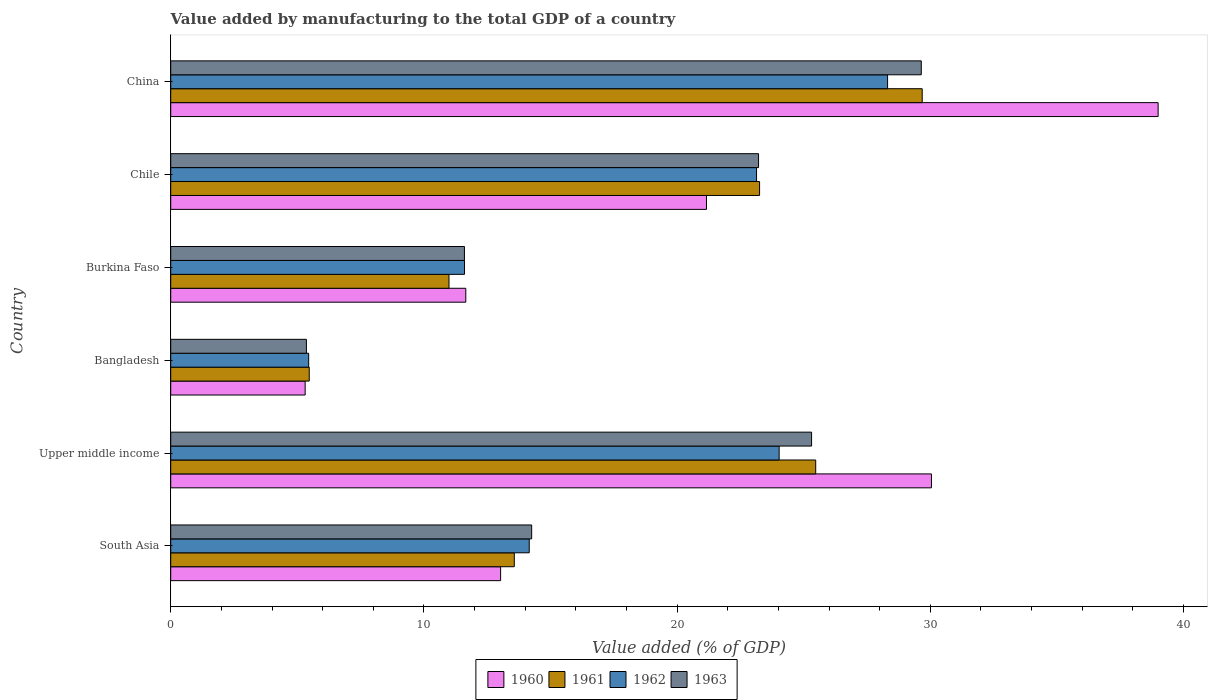How many groups of bars are there?
Ensure brevity in your answer.  6. Are the number of bars per tick equal to the number of legend labels?
Offer a terse response. Yes. How many bars are there on the 1st tick from the top?
Offer a very short reply. 4. How many bars are there on the 4th tick from the bottom?
Provide a succinct answer. 4. What is the label of the 2nd group of bars from the top?
Keep it short and to the point. Chile. What is the value added by manufacturing to the total GDP in 1963 in Bangladesh?
Offer a terse response. 5.36. Across all countries, what is the maximum value added by manufacturing to the total GDP in 1960?
Your answer should be compact. 39. Across all countries, what is the minimum value added by manufacturing to the total GDP in 1960?
Make the answer very short. 5.31. In which country was the value added by manufacturing to the total GDP in 1961 minimum?
Ensure brevity in your answer.  Bangladesh. What is the total value added by manufacturing to the total GDP in 1961 in the graph?
Offer a terse response. 108.44. What is the difference between the value added by manufacturing to the total GDP in 1961 in Bangladesh and that in Upper middle income?
Offer a terse response. -20. What is the difference between the value added by manufacturing to the total GDP in 1961 in South Asia and the value added by manufacturing to the total GDP in 1962 in China?
Make the answer very short. -14.74. What is the average value added by manufacturing to the total GDP in 1962 per country?
Give a very brief answer. 17.78. What is the difference between the value added by manufacturing to the total GDP in 1963 and value added by manufacturing to the total GDP in 1960 in Burkina Faso?
Your response must be concise. -0.05. What is the ratio of the value added by manufacturing to the total GDP in 1962 in Bangladesh to that in Chile?
Offer a terse response. 0.24. Is the difference between the value added by manufacturing to the total GDP in 1963 in Bangladesh and South Asia greater than the difference between the value added by manufacturing to the total GDP in 1960 in Bangladesh and South Asia?
Ensure brevity in your answer.  No. What is the difference between the highest and the second highest value added by manufacturing to the total GDP in 1963?
Offer a very short reply. 4.33. What is the difference between the highest and the lowest value added by manufacturing to the total GDP in 1961?
Ensure brevity in your answer.  24.21. Is the sum of the value added by manufacturing to the total GDP in 1962 in Burkina Faso and Chile greater than the maximum value added by manufacturing to the total GDP in 1961 across all countries?
Your answer should be compact. Yes. Is it the case that in every country, the sum of the value added by manufacturing to the total GDP in 1962 and value added by manufacturing to the total GDP in 1963 is greater than the sum of value added by manufacturing to the total GDP in 1960 and value added by manufacturing to the total GDP in 1961?
Ensure brevity in your answer.  No. What does the 3rd bar from the top in Upper middle income represents?
Provide a succinct answer. 1961. Is it the case that in every country, the sum of the value added by manufacturing to the total GDP in 1960 and value added by manufacturing to the total GDP in 1962 is greater than the value added by manufacturing to the total GDP in 1963?
Provide a short and direct response. Yes. How many bars are there?
Ensure brevity in your answer.  24. Are all the bars in the graph horizontal?
Your answer should be very brief. Yes. Are the values on the major ticks of X-axis written in scientific E-notation?
Provide a succinct answer. No. Does the graph contain any zero values?
Your answer should be very brief. No. Does the graph contain grids?
Ensure brevity in your answer.  No. How are the legend labels stacked?
Offer a terse response. Horizontal. What is the title of the graph?
Offer a very short reply. Value added by manufacturing to the total GDP of a country. Does "2006" appear as one of the legend labels in the graph?
Keep it short and to the point. No. What is the label or title of the X-axis?
Keep it short and to the point. Value added (% of GDP). What is the label or title of the Y-axis?
Your answer should be compact. Country. What is the Value added (% of GDP) of 1960 in South Asia?
Your answer should be very brief. 13.03. What is the Value added (% of GDP) in 1961 in South Asia?
Make the answer very short. 13.57. What is the Value added (% of GDP) in 1962 in South Asia?
Offer a terse response. 14.16. What is the Value added (% of GDP) of 1963 in South Asia?
Offer a terse response. 14.26. What is the Value added (% of GDP) of 1960 in Upper middle income?
Provide a succinct answer. 30.05. What is the Value added (% of GDP) in 1961 in Upper middle income?
Ensure brevity in your answer.  25.47. What is the Value added (% of GDP) of 1962 in Upper middle income?
Your answer should be very brief. 24.03. What is the Value added (% of GDP) in 1963 in Upper middle income?
Your answer should be compact. 25.31. What is the Value added (% of GDP) in 1960 in Bangladesh?
Make the answer very short. 5.31. What is the Value added (% of GDP) of 1961 in Bangladesh?
Provide a succinct answer. 5.47. What is the Value added (% of GDP) of 1962 in Bangladesh?
Provide a succinct answer. 5.45. What is the Value added (% of GDP) in 1963 in Bangladesh?
Give a very brief answer. 5.36. What is the Value added (% of GDP) in 1960 in Burkina Faso?
Offer a very short reply. 11.65. What is the Value added (% of GDP) of 1961 in Burkina Faso?
Offer a terse response. 10.99. What is the Value added (% of GDP) of 1962 in Burkina Faso?
Give a very brief answer. 11.6. What is the Value added (% of GDP) in 1963 in Burkina Faso?
Ensure brevity in your answer.  11.6. What is the Value added (% of GDP) in 1960 in Chile?
Your answer should be compact. 21.16. What is the Value added (% of GDP) of 1961 in Chile?
Ensure brevity in your answer.  23.26. What is the Value added (% of GDP) in 1962 in Chile?
Offer a terse response. 23.14. What is the Value added (% of GDP) in 1963 in Chile?
Make the answer very short. 23.22. What is the Value added (% of GDP) of 1960 in China?
Your answer should be compact. 39. What is the Value added (% of GDP) in 1961 in China?
Keep it short and to the point. 29.68. What is the Value added (% of GDP) of 1962 in China?
Your answer should be very brief. 28.31. What is the Value added (% of GDP) of 1963 in China?
Offer a very short reply. 29.64. Across all countries, what is the maximum Value added (% of GDP) in 1960?
Your response must be concise. 39. Across all countries, what is the maximum Value added (% of GDP) in 1961?
Ensure brevity in your answer.  29.68. Across all countries, what is the maximum Value added (% of GDP) of 1962?
Your answer should be compact. 28.31. Across all countries, what is the maximum Value added (% of GDP) in 1963?
Your answer should be compact. 29.64. Across all countries, what is the minimum Value added (% of GDP) in 1960?
Your response must be concise. 5.31. Across all countries, what is the minimum Value added (% of GDP) of 1961?
Make the answer very short. 5.47. Across all countries, what is the minimum Value added (% of GDP) of 1962?
Provide a succinct answer. 5.45. Across all countries, what is the minimum Value added (% of GDP) of 1963?
Give a very brief answer. 5.36. What is the total Value added (% of GDP) of 1960 in the graph?
Your answer should be very brief. 120.2. What is the total Value added (% of GDP) in 1961 in the graph?
Your response must be concise. 108.44. What is the total Value added (% of GDP) of 1962 in the graph?
Your answer should be very brief. 106.69. What is the total Value added (% of GDP) in 1963 in the graph?
Your answer should be compact. 109.39. What is the difference between the Value added (% of GDP) of 1960 in South Asia and that in Upper middle income?
Your answer should be very brief. -17.02. What is the difference between the Value added (% of GDP) in 1961 in South Asia and that in Upper middle income?
Your answer should be compact. -11.9. What is the difference between the Value added (% of GDP) of 1962 in South Asia and that in Upper middle income?
Your answer should be compact. -9.87. What is the difference between the Value added (% of GDP) of 1963 in South Asia and that in Upper middle income?
Your response must be concise. -11.05. What is the difference between the Value added (% of GDP) of 1960 in South Asia and that in Bangladesh?
Provide a succinct answer. 7.72. What is the difference between the Value added (% of GDP) of 1961 in South Asia and that in Bangladesh?
Provide a succinct answer. 8.1. What is the difference between the Value added (% of GDP) of 1962 in South Asia and that in Bangladesh?
Offer a terse response. 8.71. What is the difference between the Value added (% of GDP) of 1963 in South Asia and that in Bangladesh?
Keep it short and to the point. 8.9. What is the difference between the Value added (% of GDP) in 1960 in South Asia and that in Burkina Faso?
Offer a very short reply. 1.37. What is the difference between the Value added (% of GDP) of 1961 in South Asia and that in Burkina Faso?
Your answer should be very brief. 2.58. What is the difference between the Value added (% of GDP) in 1962 in South Asia and that in Burkina Faso?
Provide a short and direct response. 2.56. What is the difference between the Value added (% of GDP) of 1963 in South Asia and that in Burkina Faso?
Give a very brief answer. 2.66. What is the difference between the Value added (% of GDP) in 1960 in South Asia and that in Chile?
Your answer should be very brief. -8.13. What is the difference between the Value added (% of GDP) of 1961 in South Asia and that in Chile?
Your answer should be compact. -9.69. What is the difference between the Value added (% of GDP) in 1962 in South Asia and that in Chile?
Make the answer very short. -8.98. What is the difference between the Value added (% of GDP) in 1963 in South Asia and that in Chile?
Your answer should be compact. -8.96. What is the difference between the Value added (% of GDP) of 1960 in South Asia and that in China?
Provide a succinct answer. -25.97. What is the difference between the Value added (% of GDP) in 1961 in South Asia and that in China?
Ensure brevity in your answer.  -16.11. What is the difference between the Value added (% of GDP) in 1962 in South Asia and that in China?
Your answer should be compact. -14.15. What is the difference between the Value added (% of GDP) in 1963 in South Asia and that in China?
Give a very brief answer. -15.39. What is the difference between the Value added (% of GDP) in 1960 in Upper middle income and that in Bangladesh?
Give a very brief answer. 24.74. What is the difference between the Value added (% of GDP) in 1961 in Upper middle income and that in Bangladesh?
Keep it short and to the point. 20. What is the difference between the Value added (% of GDP) of 1962 in Upper middle income and that in Bangladesh?
Offer a terse response. 18.58. What is the difference between the Value added (% of GDP) in 1963 in Upper middle income and that in Bangladesh?
Provide a short and direct response. 19.95. What is the difference between the Value added (% of GDP) of 1960 in Upper middle income and that in Burkina Faso?
Make the answer very short. 18.39. What is the difference between the Value added (% of GDP) in 1961 in Upper middle income and that in Burkina Faso?
Give a very brief answer. 14.48. What is the difference between the Value added (% of GDP) in 1962 in Upper middle income and that in Burkina Faso?
Your response must be concise. 12.43. What is the difference between the Value added (% of GDP) in 1963 in Upper middle income and that in Burkina Faso?
Your answer should be very brief. 13.71. What is the difference between the Value added (% of GDP) of 1960 in Upper middle income and that in Chile?
Your response must be concise. 8.89. What is the difference between the Value added (% of GDP) in 1961 in Upper middle income and that in Chile?
Ensure brevity in your answer.  2.22. What is the difference between the Value added (% of GDP) in 1962 in Upper middle income and that in Chile?
Keep it short and to the point. 0.89. What is the difference between the Value added (% of GDP) of 1963 in Upper middle income and that in Chile?
Ensure brevity in your answer.  2.09. What is the difference between the Value added (% of GDP) in 1960 in Upper middle income and that in China?
Make the answer very short. -8.95. What is the difference between the Value added (% of GDP) in 1961 in Upper middle income and that in China?
Provide a short and direct response. -4.21. What is the difference between the Value added (% of GDP) in 1962 in Upper middle income and that in China?
Your answer should be compact. -4.28. What is the difference between the Value added (% of GDP) in 1963 in Upper middle income and that in China?
Offer a terse response. -4.33. What is the difference between the Value added (% of GDP) of 1960 in Bangladesh and that in Burkina Faso?
Provide a succinct answer. -6.34. What is the difference between the Value added (% of GDP) in 1961 in Bangladesh and that in Burkina Faso?
Offer a very short reply. -5.52. What is the difference between the Value added (% of GDP) in 1962 in Bangladesh and that in Burkina Faso?
Keep it short and to the point. -6.16. What is the difference between the Value added (% of GDP) in 1963 in Bangladesh and that in Burkina Faso?
Keep it short and to the point. -6.24. What is the difference between the Value added (% of GDP) in 1960 in Bangladesh and that in Chile?
Make the answer very short. -15.85. What is the difference between the Value added (% of GDP) of 1961 in Bangladesh and that in Chile?
Your answer should be compact. -17.79. What is the difference between the Value added (% of GDP) in 1962 in Bangladesh and that in Chile?
Provide a succinct answer. -17.69. What is the difference between the Value added (% of GDP) of 1963 in Bangladesh and that in Chile?
Make the answer very short. -17.86. What is the difference between the Value added (% of GDP) of 1960 in Bangladesh and that in China?
Provide a short and direct response. -33.69. What is the difference between the Value added (% of GDP) in 1961 in Bangladesh and that in China?
Your response must be concise. -24.21. What is the difference between the Value added (% of GDP) in 1962 in Bangladesh and that in China?
Ensure brevity in your answer.  -22.86. What is the difference between the Value added (% of GDP) of 1963 in Bangladesh and that in China?
Your response must be concise. -24.28. What is the difference between the Value added (% of GDP) of 1960 in Burkina Faso and that in Chile?
Provide a succinct answer. -9.51. What is the difference between the Value added (% of GDP) of 1961 in Burkina Faso and that in Chile?
Provide a succinct answer. -12.27. What is the difference between the Value added (% of GDP) of 1962 in Burkina Faso and that in Chile?
Ensure brevity in your answer.  -11.53. What is the difference between the Value added (% of GDP) in 1963 in Burkina Faso and that in Chile?
Your answer should be compact. -11.62. What is the difference between the Value added (% of GDP) of 1960 in Burkina Faso and that in China?
Your response must be concise. -27.34. What is the difference between the Value added (% of GDP) in 1961 in Burkina Faso and that in China?
Provide a short and direct response. -18.69. What is the difference between the Value added (% of GDP) in 1962 in Burkina Faso and that in China?
Provide a succinct answer. -16.71. What is the difference between the Value added (% of GDP) of 1963 in Burkina Faso and that in China?
Make the answer very short. -18.04. What is the difference between the Value added (% of GDP) of 1960 in Chile and that in China?
Give a very brief answer. -17.84. What is the difference between the Value added (% of GDP) of 1961 in Chile and that in China?
Your answer should be very brief. -6.42. What is the difference between the Value added (% of GDP) in 1962 in Chile and that in China?
Your answer should be very brief. -5.17. What is the difference between the Value added (% of GDP) in 1963 in Chile and that in China?
Offer a very short reply. -6.43. What is the difference between the Value added (% of GDP) of 1960 in South Asia and the Value added (% of GDP) of 1961 in Upper middle income?
Provide a succinct answer. -12.44. What is the difference between the Value added (% of GDP) in 1960 in South Asia and the Value added (% of GDP) in 1962 in Upper middle income?
Provide a short and direct response. -11. What is the difference between the Value added (% of GDP) in 1960 in South Asia and the Value added (% of GDP) in 1963 in Upper middle income?
Provide a short and direct response. -12.28. What is the difference between the Value added (% of GDP) in 1961 in South Asia and the Value added (% of GDP) in 1962 in Upper middle income?
Your answer should be compact. -10.46. What is the difference between the Value added (% of GDP) of 1961 in South Asia and the Value added (% of GDP) of 1963 in Upper middle income?
Offer a terse response. -11.74. What is the difference between the Value added (% of GDP) in 1962 in South Asia and the Value added (% of GDP) in 1963 in Upper middle income?
Your response must be concise. -11.15. What is the difference between the Value added (% of GDP) in 1960 in South Asia and the Value added (% of GDP) in 1961 in Bangladesh?
Ensure brevity in your answer.  7.56. What is the difference between the Value added (% of GDP) in 1960 in South Asia and the Value added (% of GDP) in 1962 in Bangladesh?
Provide a short and direct response. 7.58. What is the difference between the Value added (% of GDP) of 1960 in South Asia and the Value added (% of GDP) of 1963 in Bangladesh?
Your answer should be compact. 7.67. What is the difference between the Value added (% of GDP) in 1961 in South Asia and the Value added (% of GDP) in 1962 in Bangladesh?
Offer a terse response. 8.12. What is the difference between the Value added (% of GDP) of 1961 in South Asia and the Value added (% of GDP) of 1963 in Bangladesh?
Offer a terse response. 8.21. What is the difference between the Value added (% of GDP) in 1962 in South Asia and the Value added (% of GDP) in 1963 in Bangladesh?
Offer a terse response. 8.8. What is the difference between the Value added (% of GDP) in 1960 in South Asia and the Value added (% of GDP) in 1961 in Burkina Faso?
Your response must be concise. 2.04. What is the difference between the Value added (% of GDP) of 1960 in South Asia and the Value added (% of GDP) of 1962 in Burkina Faso?
Your answer should be compact. 1.43. What is the difference between the Value added (% of GDP) of 1960 in South Asia and the Value added (% of GDP) of 1963 in Burkina Faso?
Keep it short and to the point. 1.43. What is the difference between the Value added (% of GDP) in 1961 in South Asia and the Value added (% of GDP) in 1962 in Burkina Faso?
Your answer should be compact. 1.97. What is the difference between the Value added (% of GDP) in 1961 in South Asia and the Value added (% of GDP) in 1963 in Burkina Faso?
Your response must be concise. 1.97. What is the difference between the Value added (% of GDP) in 1962 in South Asia and the Value added (% of GDP) in 1963 in Burkina Faso?
Your answer should be very brief. 2.56. What is the difference between the Value added (% of GDP) in 1960 in South Asia and the Value added (% of GDP) in 1961 in Chile?
Offer a very short reply. -10.23. What is the difference between the Value added (% of GDP) of 1960 in South Asia and the Value added (% of GDP) of 1962 in Chile?
Your answer should be compact. -10.11. What is the difference between the Value added (% of GDP) in 1960 in South Asia and the Value added (% of GDP) in 1963 in Chile?
Offer a terse response. -10.19. What is the difference between the Value added (% of GDP) of 1961 in South Asia and the Value added (% of GDP) of 1962 in Chile?
Ensure brevity in your answer.  -9.57. What is the difference between the Value added (% of GDP) of 1961 in South Asia and the Value added (% of GDP) of 1963 in Chile?
Provide a succinct answer. -9.65. What is the difference between the Value added (% of GDP) of 1962 in South Asia and the Value added (% of GDP) of 1963 in Chile?
Keep it short and to the point. -9.06. What is the difference between the Value added (% of GDP) of 1960 in South Asia and the Value added (% of GDP) of 1961 in China?
Offer a very short reply. -16.65. What is the difference between the Value added (% of GDP) of 1960 in South Asia and the Value added (% of GDP) of 1962 in China?
Provide a short and direct response. -15.28. What is the difference between the Value added (% of GDP) of 1960 in South Asia and the Value added (% of GDP) of 1963 in China?
Provide a succinct answer. -16.62. What is the difference between the Value added (% of GDP) of 1961 in South Asia and the Value added (% of GDP) of 1962 in China?
Your answer should be compact. -14.74. What is the difference between the Value added (% of GDP) of 1961 in South Asia and the Value added (% of GDP) of 1963 in China?
Make the answer very short. -16.07. What is the difference between the Value added (% of GDP) in 1962 in South Asia and the Value added (% of GDP) in 1963 in China?
Give a very brief answer. -15.48. What is the difference between the Value added (% of GDP) of 1960 in Upper middle income and the Value added (% of GDP) of 1961 in Bangladesh?
Provide a short and direct response. 24.57. What is the difference between the Value added (% of GDP) in 1960 in Upper middle income and the Value added (% of GDP) in 1962 in Bangladesh?
Offer a terse response. 24.6. What is the difference between the Value added (% of GDP) of 1960 in Upper middle income and the Value added (% of GDP) of 1963 in Bangladesh?
Your response must be concise. 24.69. What is the difference between the Value added (% of GDP) in 1961 in Upper middle income and the Value added (% of GDP) in 1962 in Bangladesh?
Provide a succinct answer. 20.03. What is the difference between the Value added (% of GDP) in 1961 in Upper middle income and the Value added (% of GDP) in 1963 in Bangladesh?
Your answer should be very brief. 20.11. What is the difference between the Value added (% of GDP) of 1962 in Upper middle income and the Value added (% of GDP) of 1963 in Bangladesh?
Your response must be concise. 18.67. What is the difference between the Value added (% of GDP) in 1960 in Upper middle income and the Value added (% of GDP) in 1961 in Burkina Faso?
Provide a succinct answer. 19.05. What is the difference between the Value added (% of GDP) in 1960 in Upper middle income and the Value added (% of GDP) in 1962 in Burkina Faso?
Make the answer very short. 18.44. What is the difference between the Value added (% of GDP) in 1960 in Upper middle income and the Value added (% of GDP) in 1963 in Burkina Faso?
Your answer should be compact. 18.44. What is the difference between the Value added (% of GDP) in 1961 in Upper middle income and the Value added (% of GDP) in 1962 in Burkina Faso?
Offer a terse response. 13.87. What is the difference between the Value added (% of GDP) in 1961 in Upper middle income and the Value added (% of GDP) in 1963 in Burkina Faso?
Provide a succinct answer. 13.87. What is the difference between the Value added (% of GDP) of 1962 in Upper middle income and the Value added (% of GDP) of 1963 in Burkina Faso?
Give a very brief answer. 12.43. What is the difference between the Value added (% of GDP) of 1960 in Upper middle income and the Value added (% of GDP) of 1961 in Chile?
Your response must be concise. 6.79. What is the difference between the Value added (% of GDP) of 1960 in Upper middle income and the Value added (% of GDP) of 1962 in Chile?
Offer a very short reply. 6.91. What is the difference between the Value added (% of GDP) of 1960 in Upper middle income and the Value added (% of GDP) of 1963 in Chile?
Keep it short and to the point. 6.83. What is the difference between the Value added (% of GDP) of 1961 in Upper middle income and the Value added (% of GDP) of 1962 in Chile?
Your answer should be very brief. 2.34. What is the difference between the Value added (% of GDP) in 1961 in Upper middle income and the Value added (% of GDP) in 1963 in Chile?
Your answer should be very brief. 2.26. What is the difference between the Value added (% of GDP) in 1962 in Upper middle income and the Value added (% of GDP) in 1963 in Chile?
Keep it short and to the point. 0.81. What is the difference between the Value added (% of GDP) of 1960 in Upper middle income and the Value added (% of GDP) of 1961 in China?
Give a very brief answer. 0.37. What is the difference between the Value added (% of GDP) in 1960 in Upper middle income and the Value added (% of GDP) in 1962 in China?
Provide a short and direct response. 1.73. What is the difference between the Value added (% of GDP) in 1960 in Upper middle income and the Value added (% of GDP) in 1963 in China?
Provide a succinct answer. 0.4. What is the difference between the Value added (% of GDP) of 1961 in Upper middle income and the Value added (% of GDP) of 1962 in China?
Offer a very short reply. -2.84. What is the difference between the Value added (% of GDP) in 1961 in Upper middle income and the Value added (% of GDP) in 1963 in China?
Ensure brevity in your answer.  -4.17. What is the difference between the Value added (% of GDP) in 1962 in Upper middle income and the Value added (% of GDP) in 1963 in China?
Make the answer very short. -5.61. What is the difference between the Value added (% of GDP) of 1960 in Bangladesh and the Value added (% of GDP) of 1961 in Burkina Faso?
Provide a succinct answer. -5.68. What is the difference between the Value added (% of GDP) of 1960 in Bangladesh and the Value added (% of GDP) of 1962 in Burkina Faso?
Provide a short and direct response. -6.29. What is the difference between the Value added (% of GDP) of 1960 in Bangladesh and the Value added (% of GDP) of 1963 in Burkina Faso?
Provide a succinct answer. -6.29. What is the difference between the Value added (% of GDP) of 1961 in Bangladesh and the Value added (% of GDP) of 1962 in Burkina Faso?
Offer a terse response. -6.13. What is the difference between the Value added (% of GDP) in 1961 in Bangladesh and the Value added (% of GDP) in 1963 in Burkina Faso?
Provide a short and direct response. -6.13. What is the difference between the Value added (% of GDP) of 1962 in Bangladesh and the Value added (% of GDP) of 1963 in Burkina Faso?
Your answer should be compact. -6.15. What is the difference between the Value added (% of GDP) in 1960 in Bangladesh and the Value added (% of GDP) in 1961 in Chile?
Your response must be concise. -17.95. What is the difference between the Value added (% of GDP) in 1960 in Bangladesh and the Value added (% of GDP) in 1962 in Chile?
Keep it short and to the point. -17.83. What is the difference between the Value added (% of GDP) in 1960 in Bangladesh and the Value added (% of GDP) in 1963 in Chile?
Provide a short and direct response. -17.91. What is the difference between the Value added (% of GDP) of 1961 in Bangladesh and the Value added (% of GDP) of 1962 in Chile?
Provide a short and direct response. -17.67. What is the difference between the Value added (% of GDP) in 1961 in Bangladesh and the Value added (% of GDP) in 1963 in Chile?
Your response must be concise. -17.75. What is the difference between the Value added (% of GDP) in 1962 in Bangladesh and the Value added (% of GDP) in 1963 in Chile?
Your answer should be very brief. -17.77. What is the difference between the Value added (% of GDP) in 1960 in Bangladesh and the Value added (% of GDP) in 1961 in China?
Offer a terse response. -24.37. What is the difference between the Value added (% of GDP) in 1960 in Bangladesh and the Value added (% of GDP) in 1962 in China?
Give a very brief answer. -23. What is the difference between the Value added (% of GDP) in 1960 in Bangladesh and the Value added (% of GDP) in 1963 in China?
Offer a very short reply. -24.33. What is the difference between the Value added (% of GDP) in 1961 in Bangladesh and the Value added (% of GDP) in 1962 in China?
Provide a succinct answer. -22.84. What is the difference between the Value added (% of GDP) of 1961 in Bangladesh and the Value added (% of GDP) of 1963 in China?
Make the answer very short. -24.17. What is the difference between the Value added (% of GDP) in 1962 in Bangladesh and the Value added (% of GDP) in 1963 in China?
Offer a terse response. -24.2. What is the difference between the Value added (% of GDP) of 1960 in Burkina Faso and the Value added (% of GDP) of 1961 in Chile?
Provide a short and direct response. -11.6. What is the difference between the Value added (% of GDP) in 1960 in Burkina Faso and the Value added (% of GDP) in 1962 in Chile?
Your answer should be compact. -11.48. What is the difference between the Value added (% of GDP) in 1960 in Burkina Faso and the Value added (% of GDP) in 1963 in Chile?
Provide a succinct answer. -11.56. What is the difference between the Value added (% of GDP) of 1961 in Burkina Faso and the Value added (% of GDP) of 1962 in Chile?
Give a very brief answer. -12.15. What is the difference between the Value added (% of GDP) in 1961 in Burkina Faso and the Value added (% of GDP) in 1963 in Chile?
Ensure brevity in your answer.  -12.23. What is the difference between the Value added (% of GDP) in 1962 in Burkina Faso and the Value added (% of GDP) in 1963 in Chile?
Offer a terse response. -11.61. What is the difference between the Value added (% of GDP) of 1960 in Burkina Faso and the Value added (% of GDP) of 1961 in China?
Ensure brevity in your answer.  -18.03. What is the difference between the Value added (% of GDP) of 1960 in Burkina Faso and the Value added (% of GDP) of 1962 in China?
Provide a succinct answer. -16.66. What is the difference between the Value added (% of GDP) in 1960 in Burkina Faso and the Value added (% of GDP) in 1963 in China?
Your answer should be very brief. -17.99. What is the difference between the Value added (% of GDP) in 1961 in Burkina Faso and the Value added (% of GDP) in 1962 in China?
Offer a very short reply. -17.32. What is the difference between the Value added (% of GDP) of 1961 in Burkina Faso and the Value added (% of GDP) of 1963 in China?
Give a very brief answer. -18.65. What is the difference between the Value added (% of GDP) in 1962 in Burkina Faso and the Value added (% of GDP) in 1963 in China?
Offer a terse response. -18.04. What is the difference between the Value added (% of GDP) of 1960 in Chile and the Value added (% of GDP) of 1961 in China?
Provide a succinct answer. -8.52. What is the difference between the Value added (% of GDP) of 1960 in Chile and the Value added (% of GDP) of 1962 in China?
Your answer should be very brief. -7.15. What is the difference between the Value added (% of GDP) in 1960 in Chile and the Value added (% of GDP) in 1963 in China?
Provide a short and direct response. -8.48. What is the difference between the Value added (% of GDP) of 1961 in Chile and the Value added (% of GDP) of 1962 in China?
Offer a very short reply. -5.06. What is the difference between the Value added (% of GDP) of 1961 in Chile and the Value added (% of GDP) of 1963 in China?
Ensure brevity in your answer.  -6.39. What is the difference between the Value added (% of GDP) in 1962 in Chile and the Value added (% of GDP) in 1963 in China?
Make the answer very short. -6.51. What is the average Value added (% of GDP) of 1960 per country?
Give a very brief answer. 20.03. What is the average Value added (% of GDP) of 1961 per country?
Ensure brevity in your answer.  18.07. What is the average Value added (% of GDP) in 1962 per country?
Your response must be concise. 17.78. What is the average Value added (% of GDP) in 1963 per country?
Your answer should be very brief. 18.23. What is the difference between the Value added (% of GDP) of 1960 and Value added (% of GDP) of 1961 in South Asia?
Give a very brief answer. -0.54. What is the difference between the Value added (% of GDP) in 1960 and Value added (% of GDP) in 1962 in South Asia?
Keep it short and to the point. -1.13. What is the difference between the Value added (% of GDP) of 1960 and Value added (% of GDP) of 1963 in South Asia?
Make the answer very short. -1.23. What is the difference between the Value added (% of GDP) of 1961 and Value added (% of GDP) of 1962 in South Asia?
Offer a very short reply. -0.59. What is the difference between the Value added (% of GDP) in 1961 and Value added (% of GDP) in 1963 in South Asia?
Keep it short and to the point. -0.69. What is the difference between the Value added (% of GDP) of 1962 and Value added (% of GDP) of 1963 in South Asia?
Make the answer very short. -0.1. What is the difference between the Value added (% of GDP) of 1960 and Value added (% of GDP) of 1961 in Upper middle income?
Give a very brief answer. 4.57. What is the difference between the Value added (% of GDP) of 1960 and Value added (% of GDP) of 1962 in Upper middle income?
Make the answer very short. 6.01. What is the difference between the Value added (% of GDP) in 1960 and Value added (% of GDP) in 1963 in Upper middle income?
Provide a short and direct response. 4.73. What is the difference between the Value added (% of GDP) of 1961 and Value added (% of GDP) of 1962 in Upper middle income?
Your response must be concise. 1.44. What is the difference between the Value added (% of GDP) of 1961 and Value added (% of GDP) of 1963 in Upper middle income?
Your answer should be compact. 0.16. What is the difference between the Value added (% of GDP) of 1962 and Value added (% of GDP) of 1963 in Upper middle income?
Give a very brief answer. -1.28. What is the difference between the Value added (% of GDP) in 1960 and Value added (% of GDP) in 1961 in Bangladesh?
Give a very brief answer. -0.16. What is the difference between the Value added (% of GDP) of 1960 and Value added (% of GDP) of 1962 in Bangladesh?
Provide a short and direct response. -0.14. What is the difference between the Value added (% of GDP) in 1960 and Value added (% of GDP) in 1963 in Bangladesh?
Your answer should be very brief. -0.05. What is the difference between the Value added (% of GDP) of 1961 and Value added (% of GDP) of 1962 in Bangladesh?
Provide a short and direct response. 0.02. What is the difference between the Value added (% of GDP) in 1961 and Value added (% of GDP) in 1963 in Bangladesh?
Make the answer very short. 0.11. What is the difference between the Value added (% of GDP) of 1962 and Value added (% of GDP) of 1963 in Bangladesh?
Your response must be concise. 0.09. What is the difference between the Value added (% of GDP) of 1960 and Value added (% of GDP) of 1961 in Burkina Faso?
Provide a succinct answer. 0.66. What is the difference between the Value added (% of GDP) of 1960 and Value added (% of GDP) of 1962 in Burkina Faso?
Your response must be concise. 0.05. What is the difference between the Value added (% of GDP) of 1960 and Value added (% of GDP) of 1963 in Burkina Faso?
Give a very brief answer. 0.05. What is the difference between the Value added (% of GDP) in 1961 and Value added (% of GDP) in 1962 in Burkina Faso?
Make the answer very short. -0.61. What is the difference between the Value added (% of GDP) in 1961 and Value added (% of GDP) in 1963 in Burkina Faso?
Provide a succinct answer. -0.61. What is the difference between the Value added (% of GDP) of 1962 and Value added (% of GDP) of 1963 in Burkina Faso?
Your answer should be very brief. 0. What is the difference between the Value added (% of GDP) of 1960 and Value added (% of GDP) of 1961 in Chile?
Give a very brief answer. -2.1. What is the difference between the Value added (% of GDP) of 1960 and Value added (% of GDP) of 1962 in Chile?
Your answer should be very brief. -1.98. What is the difference between the Value added (% of GDP) of 1960 and Value added (% of GDP) of 1963 in Chile?
Ensure brevity in your answer.  -2.06. What is the difference between the Value added (% of GDP) of 1961 and Value added (% of GDP) of 1962 in Chile?
Provide a short and direct response. 0.12. What is the difference between the Value added (% of GDP) of 1961 and Value added (% of GDP) of 1963 in Chile?
Provide a short and direct response. 0.04. What is the difference between the Value added (% of GDP) of 1962 and Value added (% of GDP) of 1963 in Chile?
Your answer should be compact. -0.08. What is the difference between the Value added (% of GDP) of 1960 and Value added (% of GDP) of 1961 in China?
Provide a succinct answer. 9.32. What is the difference between the Value added (% of GDP) of 1960 and Value added (% of GDP) of 1962 in China?
Keep it short and to the point. 10.69. What is the difference between the Value added (% of GDP) in 1960 and Value added (% of GDP) in 1963 in China?
Provide a short and direct response. 9.35. What is the difference between the Value added (% of GDP) in 1961 and Value added (% of GDP) in 1962 in China?
Ensure brevity in your answer.  1.37. What is the difference between the Value added (% of GDP) in 1961 and Value added (% of GDP) in 1963 in China?
Your response must be concise. 0.04. What is the difference between the Value added (% of GDP) of 1962 and Value added (% of GDP) of 1963 in China?
Your response must be concise. -1.33. What is the ratio of the Value added (% of GDP) in 1960 in South Asia to that in Upper middle income?
Your answer should be very brief. 0.43. What is the ratio of the Value added (% of GDP) in 1961 in South Asia to that in Upper middle income?
Your answer should be very brief. 0.53. What is the ratio of the Value added (% of GDP) of 1962 in South Asia to that in Upper middle income?
Your answer should be very brief. 0.59. What is the ratio of the Value added (% of GDP) of 1963 in South Asia to that in Upper middle income?
Give a very brief answer. 0.56. What is the ratio of the Value added (% of GDP) in 1960 in South Asia to that in Bangladesh?
Give a very brief answer. 2.45. What is the ratio of the Value added (% of GDP) in 1961 in South Asia to that in Bangladesh?
Keep it short and to the point. 2.48. What is the ratio of the Value added (% of GDP) of 1962 in South Asia to that in Bangladesh?
Your answer should be very brief. 2.6. What is the ratio of the Value added (% of GDP) in 1963 in South Asia to that in Bangladesh?
Offer a very short reply. 2.66. What is the ratio of the Value added (% of GDP) in 1960 in South Asia to that in Burkina Faso?
Provide a short and direct response. 1.12. What is the ratio of the Value added (% of GDP) of 1961 in South Asia to that in Burkina Faso?
Offer a very short reply. 1.23. What is the ratio of the Value added (% of GDP) of 1962 in South Asia to that in Burkina Faso?
Make the answer very short. 1.22. What is the ratio of the Value added (% of GDP) of 1963 in South Asia to that in Burkina Faso?
Ensure brevity in your answer.  1.23. What is the ratio of the Value added (% of GDP) in 1960 in South Asia to that in Chile?
Offer a very short reply. 0.62. What is the ratio of the Value added (% of GDP) in 1961 in South Asia to that in Chile?
Give a very brief answer. 0.58. What is the ratio of the Value added (% of GDP) of 1962 in South Asia to that in Chile?
Your answer should be very brief. 0.61. What is the ratio of the Value added (% of GDP) of 1963 in South Asia to that in Chile?
Ensure brevity in your answer.  0.61. What is the ratio of the Value added (% of GDP) in 1960 in South Asia to that in China?
Provide a short and direct response. 0.33. What is the ratio of the Value added (% of GDP) in 1961 in South Asia to that in China?
Make the answer very short. 0.46. What is the ratio of the Value added (% of GDP) in 1962 in South Asia to that in China?
Keep it short and to the point. 0.5. What is the ratio of the Value added (% of GDP) of 1963 in South Asia to that in China?
Provide a short and direct response. 0.48. What is the ratio of the Value added (% of GDP) of 1960 in Upper middle income to that in Bangladesh?
Your answer should be compact. 5.66. What is the ratio of the Value added (% of GDP) of 1961 in Upper middle income to that in Bangladesh?
Give a very brief answer. 4.66. What is the ratio of the Value added (% of GDP) of 1962 in Upper middle income to that in Bangladesh?
Give a very brief answer. 4.41. What is the ratio of the Value added (% of GDP) in 1963 in Upper middle income to that in Bangladesh?
Keep it short and to the point. 4.72. What is the ratio of the Value added (% of GDP) of 1960 in Upper middle income to that in Burkina Faso?
Offer a terse response. 2.58. What is the ratio of the Value added (% of GDP) of 1961 in Upper middle income to that in Burkina Faso?
Keep it short and to the point. 2.32. What is the ratio of the Value added (% of GDP) of 1962 in Upper middle income to that in Burkina Faso?
Keep it short and to the point. 2.07. What is the ratio of the Value added (% of GDP) of 1963 in Upper middle income to that in Burkina Faso?
Your response must be concise. 2.18. What is the ratio of the Value added (% of GDP) of 1960 in Upper middle income to that in Chile?
Your answer should be compact. 1.42. What is the ratio of the Value added (% of GDP) in 1961 in Upper middle income to that in Chile?
Provide a succinct answer. 1.1. What is the ratio of the Value added (% of GDP) in 1962 in Upper middle income to that in Chile?
Your answer should be compact. 1.04. What is the ratio of the Value added (% of GDP) in 1963 in Upper middle income to that in Chile?
Make the answer very short. 1.09. What is the ratio of the Value added (% of GDP) in 1960 in Upper middle income to that in China?
Keep it short and to the point. 0.77. What is the ratio of the Value added (% of GDP) in 1961 in Upper middle income to that in China?
Your answer should be compact. 0.86. What is the ratio of the Value added (% of GDP) in 1962 in Upper middle income to that in China?
Offer a terse response. 0.85. What is the ratio of the Value added (% of GDP) of 1963 in Upper middle income to that in China?
Ensure brevity in your answer.  0.85. What is the ratio of the Value added (% of GDP) of 1960 in Bangladesh to that in Burkina Faso?
Offer a terse response. 0.46. What is the ratio of the Value added (% of GDP) in 1961 in Bangladesh to that in Burkina Faso?
Your answer should be very brief. 0.5. What is the ratio of the Value added (% of GDP) of 1962 in Bangladesh to that in Burkina Faso?
Offer a terse response. 0.47. What is the ratio of the Value added (% of GDP) in 1963 in Bangladesh to that in Burkina Faso?
Keep it short and to the point. 0.46. What is the ratio of the Value added (% of GDP) of 1960 in Bangladesh to that in Chile?
Offer a terse response. 0.25. What is the ratio of the Value added (% of GDP) of 1961 in Bangladesh to that in Chile?
Keep it short and to the point. 0.24. What is the ratio of the Value added (% of GDP) in 1962 in Bangladesh to that in Chile?
Your answer should be compact. 0.24. What is the ratio of the Value added (% of GDP) in 1963 in Bangladesh to that in Chile?
Offer a terse response. 0.23. What is the ratio of the Value added (% of GDP) in 1960 in Bangladesh to that in China?
Provide a succinct answer. 0.14. What is the ratio of the Value added (% of GDP) of 1961 in Bangladesh to that in China?
Provide a succinct answer. 0.18. What is the ratio of the Value added (% of GDP) of 1962 in Bangladesh to that in China?
Your answer should be compact. 0.19. What is the ratio of the Value added (% of GDP) in 1963 in Bangladesh to that in China?
Give a very brief answer. 0.18. What is the ratio of the Value added (% of GDP) of 1960 in Burkina Faso to that in Chile?
Offer a terse response. 0.55. What is the ratio of the Value added (% of GDP) of 1961 in Burkina Faso to that in Chile?
Provide a short and direct response. 0.47. What is the ratio of the Value added (% of GDP) in 1962 in Burkina Faso to that in Chile?
Your response must be concise. 0.5. What is the ratio of the Value added (% of GDP) of 1963 in Burkina Faso to that in Chile?
Provide a short and direct response. 0.5. What is the ratio of the Value added (% of GDP) in 1960 in Burkina Faso to that in China?
Give a very brief answer. 0.3. What is the ratio of the Value added (% of GDP) of 1961 in Burkina Faso to that in China?
Provide a short and direct response. 0.37. What is the ratio of the Value added (% of GDP) of 1962 in Burkina Faso to that in China?
Offer a terse response. 0.41. What is the ratio of the Value added (% of GDP) in 1963 in Burkina Faso to that in China?
Provide a short and direct response. 0.39. What is the ratio of the Value added (% of GDP) of 1960 in Chile to that in China?
Ensure brevity in your answer.  0.54. What is the ratio of the Value added (% of GDP) of 1961 in Chile to that in China?
Give a very brief answer. 0.78. What is the ratio of the Value added (% of GDP) in 1962 in Chile to that in China?
Provide a succinct answer. 0.82. What is the ratio of the Value added (% of GDP) of 1963 in Chile to that in China?
Give a very brief answer. 0.78. What is the difference between the highest and the second highest Value added (% of GDP) of 1960?
Provide a short and direct response. 8.95. What is the difference between the highest and the second highest Value added (% of GDP) in 1961?
Provide a short and direct response. 4.21. What is the difference between the highest and the second highest Value added (% of GDP) in 1962?
Give a very brief answer. 4.28. What is the difference between the highest and the second highest Value added (% of GDP) of 1963?
Provide a succinct answer. 4.33. What is the difference between the highest and the lowest Value added (% of GDP) of 1960?
Offer a terse response. 33.69. What is the difference between the highest and the lowest Value added (% of GDP) in 1961?
Your answer should be very brief. 24.21. What is the difference between the highest and the lowest Value added (% of GDP) of 1962?
Keep it short and to the point. 22.86. What is the difference between the highest and the lowest Value added (% of GDP) of 1963?
Your response must be concise. 24.28. 